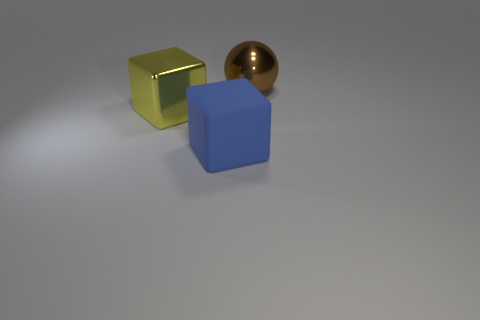Add 3 big blue rubber spheres. How many objects exist? 6 Subtract all balls. How many objects are left? 2 Add 3 large yellow objects. How many large yellow objects are left? 4 Add 3 big green cylinders. How many big green cylinders exist? 3 Subtract 0 purple cubes. How many objects are left? 3 Subtract all big gray metal blocks. Subtract all big metallic spheres. How many objects are left? 2 